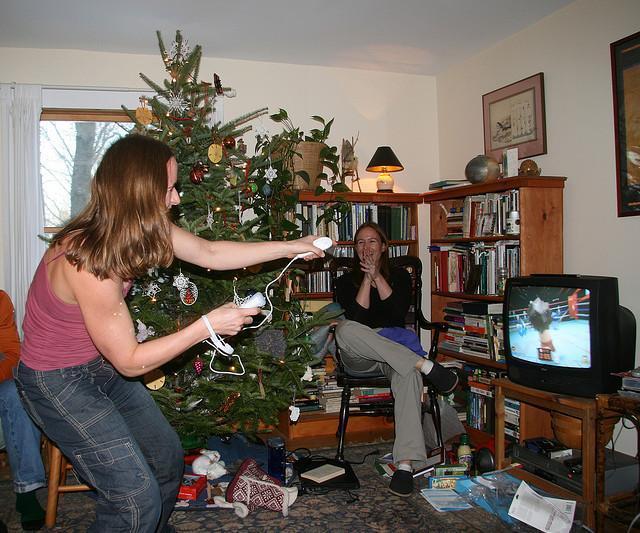How many potted plants are there?
Give a very brief answer. 1. How many people are there?
Give a very brief answer. 3. 